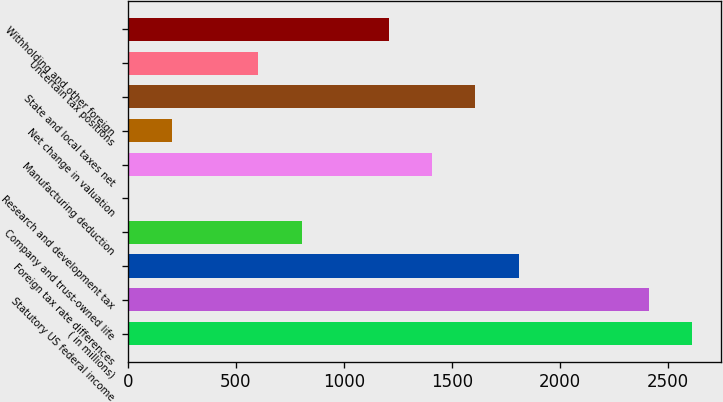Convert chart. <chart><loc_0><loc_0><loc_500><loc_500><bar_chart><fcel>( in millions)<fcel>Statutory US federal income<fcel>Foreign tax rate differences<fcel>Company and trust-owned life<fcel>Research and development tax<fcel>Manufacturing deduction<fcel>Net change in valuation<fcel>State and local taxes net<fcel>Uncertain tax positions<fcel>Withholding and other foreign<nl><fcel>2612.64<fcel>2411.76<fcel>1809.12<fcel>804.72<fcel>1.2<fcel>1407.36<fcel>202.08<fcel>1608.24<fcel>603.84<fcel>1206.48<nl></chart> 